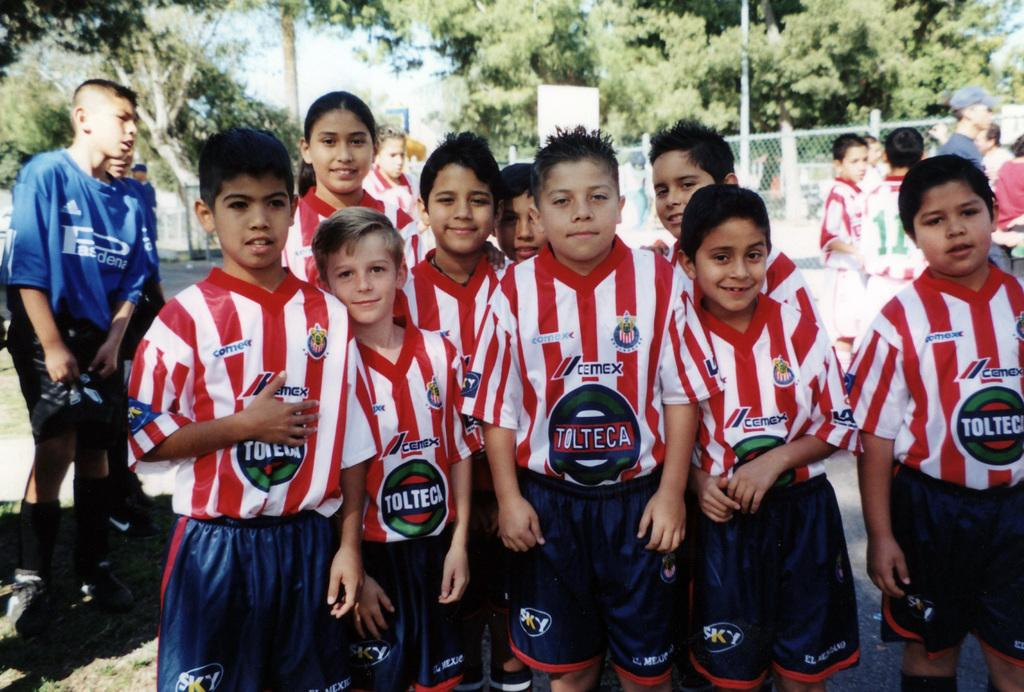<image>
Relay a brief, clear account of the picture shown. Many boys pose for a soccer photo in their Tolteca uniforms. 